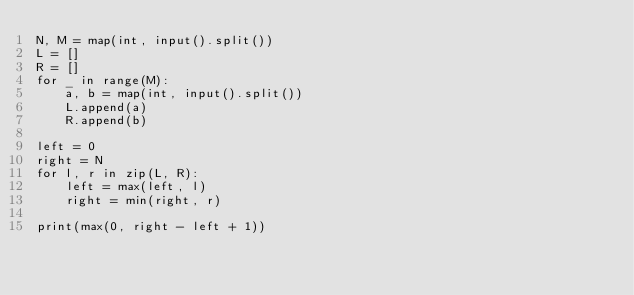<code> <loc_0><loc_0><loc_500><loc_500><_Python_>N, M = map(int, input().split())
L = []
R = []
for _ in range(M):
    a, b = map(int, input().split())
    L.append(a)
    R.append(b)

left = 0
right = N
for l, r in zip(L, R):
    left = max(left, l)
    right = min(right, r)
    
print(max(0, right - left + 1))</code> 